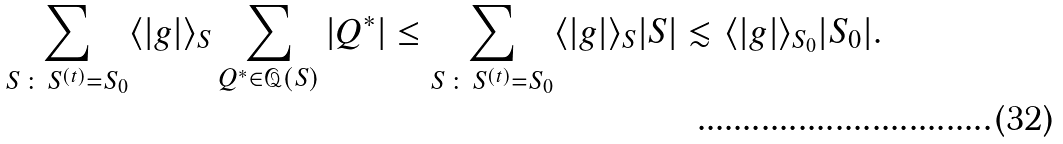<formula> <loc_0><loc_0><loc_500><loc_500>\sum _ { S \, \colon \, S ^ { ( t ) } = S _ { 0 } } \langle | g | \rangle _ { S } \sum _ { Q ^ { \ast } \in \mathcal { Q } ( S ) } | Q ^ { \ast } | & \leq \sum _ { S \, \colon \, S ^ { ( t ) } = S _ { 0 } } \langle | g | \rangle _ { S } | S | \lesssim \langle | g | \rangle _ { S _ { 0 } } | S _ { 0 } | .</formula> 